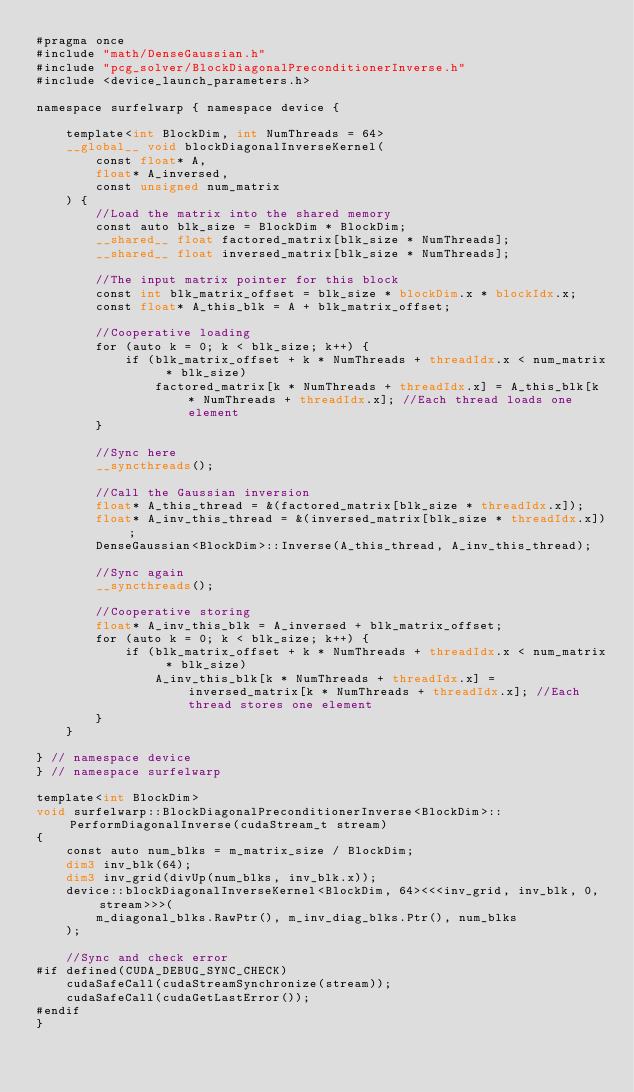<code> <loc_0><loc_0><loc_500><loc_500><_Cuda_>#pragma once
#include "math/DenseGaussian.h"
#include "pcg_solver/BlockDiagonalPreconditionerInverse.h"
#include <device_launch_parameters.h>

namespace surfelwarp { namespace device {
	
	template<int BlockDim, int NumThreads = 64>
	__global__ void blockDiagonalInverseKernel(
		const float* A,
		float* A_inversed,
		const unsigned num_matrix
	) {
		//Load the matrix into the shared memory
		const auto blk_size = BlockDim * BlockDim;
		__shared__ float factored_matrix[blk_size * NumThreads];
		__shared__ float inversed_matrix[blk_size * NumThreads];

		//The input matrix pointer for this block
		const int blk_matrix_offset = blk_size * blockDim.x * blockIdx.x;
		const float* A_this_blk = A + blk_matrix_offset;

		//Cooperative loading
		for (auto k = 0; k < blk_size; k++) {
			if (blk_matrix_offset + k * NumThreads + threadIdx.x < num_matrix * blk_size)
				factored_matrix[k * NumThreads + threadIdx.x] = A_this_blk[k * NumThreads + threadIdx.x]; //Each thread loads one element
		}

		//Sync here
		__syncthreads();

		//Call the Gaussian inversion
		float* A_this_thread = &(factored_matrix[blk_size * threadIdx.x]);
		float* A_inv_this_thread = &(inversed_matrix[blk_size * threadIdx.x]);
		DenseGaussian<BlockDim>::Inverse(A_this_thread, A_inv_this_thread);

		//Sync again
		__syncthreads();

		//Cooperative storing
		float* A_inv_this_blk = A_inversed + blk_matrix_offset;
		for (auto k = 0; k < blk_size; k++) {
			if (blk_matrix_offset + k * NumThreads + threadIdx.x < num_matrix * blk_size)
				A_inv_this_blk[k * NumThreads + threadIdx.x] = inversed_matrix[k * NumThreads + threadIdx.x]; //Each thread stores one element
		}
	}

} // namespace device
} // namespace surfelwarp

template<int BlockDim>
void surfelwarp::BlockDiagonalPreconditionerInverse<BlockDim>::PerformDiagonalInverse(cudaStream_t stream)
{
	const auto num_blks = m_matrix_size / BlockDim;
	dim3 inv_blk(64);
	dim3 inv_grid(divUp(num_blks, inv_blk.x));
	device::blockDiagonalInverseKernel<BlockDim, 64><<<inv_grid, inv_blk, 0, stream>>>(
		m_diagonal_blks.RawPtr(), m_inv_diag_blks.Ptr(), num_blks
	);
	
	//Sync and check error
#if defined(CUDA_DEBUG_SYNC_CHECK)
	cudaSafeCall(cudaStreamSynchronize(stream));
	cudaSafeCall(cudaGetLastError());
#endif
}
</code> 